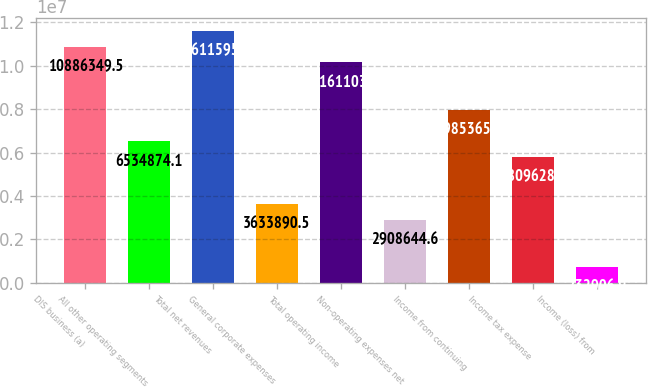Convert chart to OTSL. <chart><loc_0><loc_0><loc_500><loc_500><bar_chart><fcel>DIS business (a)<fcel>All other operating segments<fcel>Total net revenues<fcel>General corporate expenses<fcel>Total operating income<fcel>Non-operating expenses net<fcel>Income from continuing<fcel>Income tax expense<fcel>Income (loss) from<nl><fcel>1.08863e+07<fcel>6.53487e+06<fcel>1.16116e+07<fcel>3.63389e+06<fcel>1.01611e+07<fcel>2.90864e+06<fcel>7.98537e+06<fcel>5.80963e+06<fcel>732907<nl></chart> 